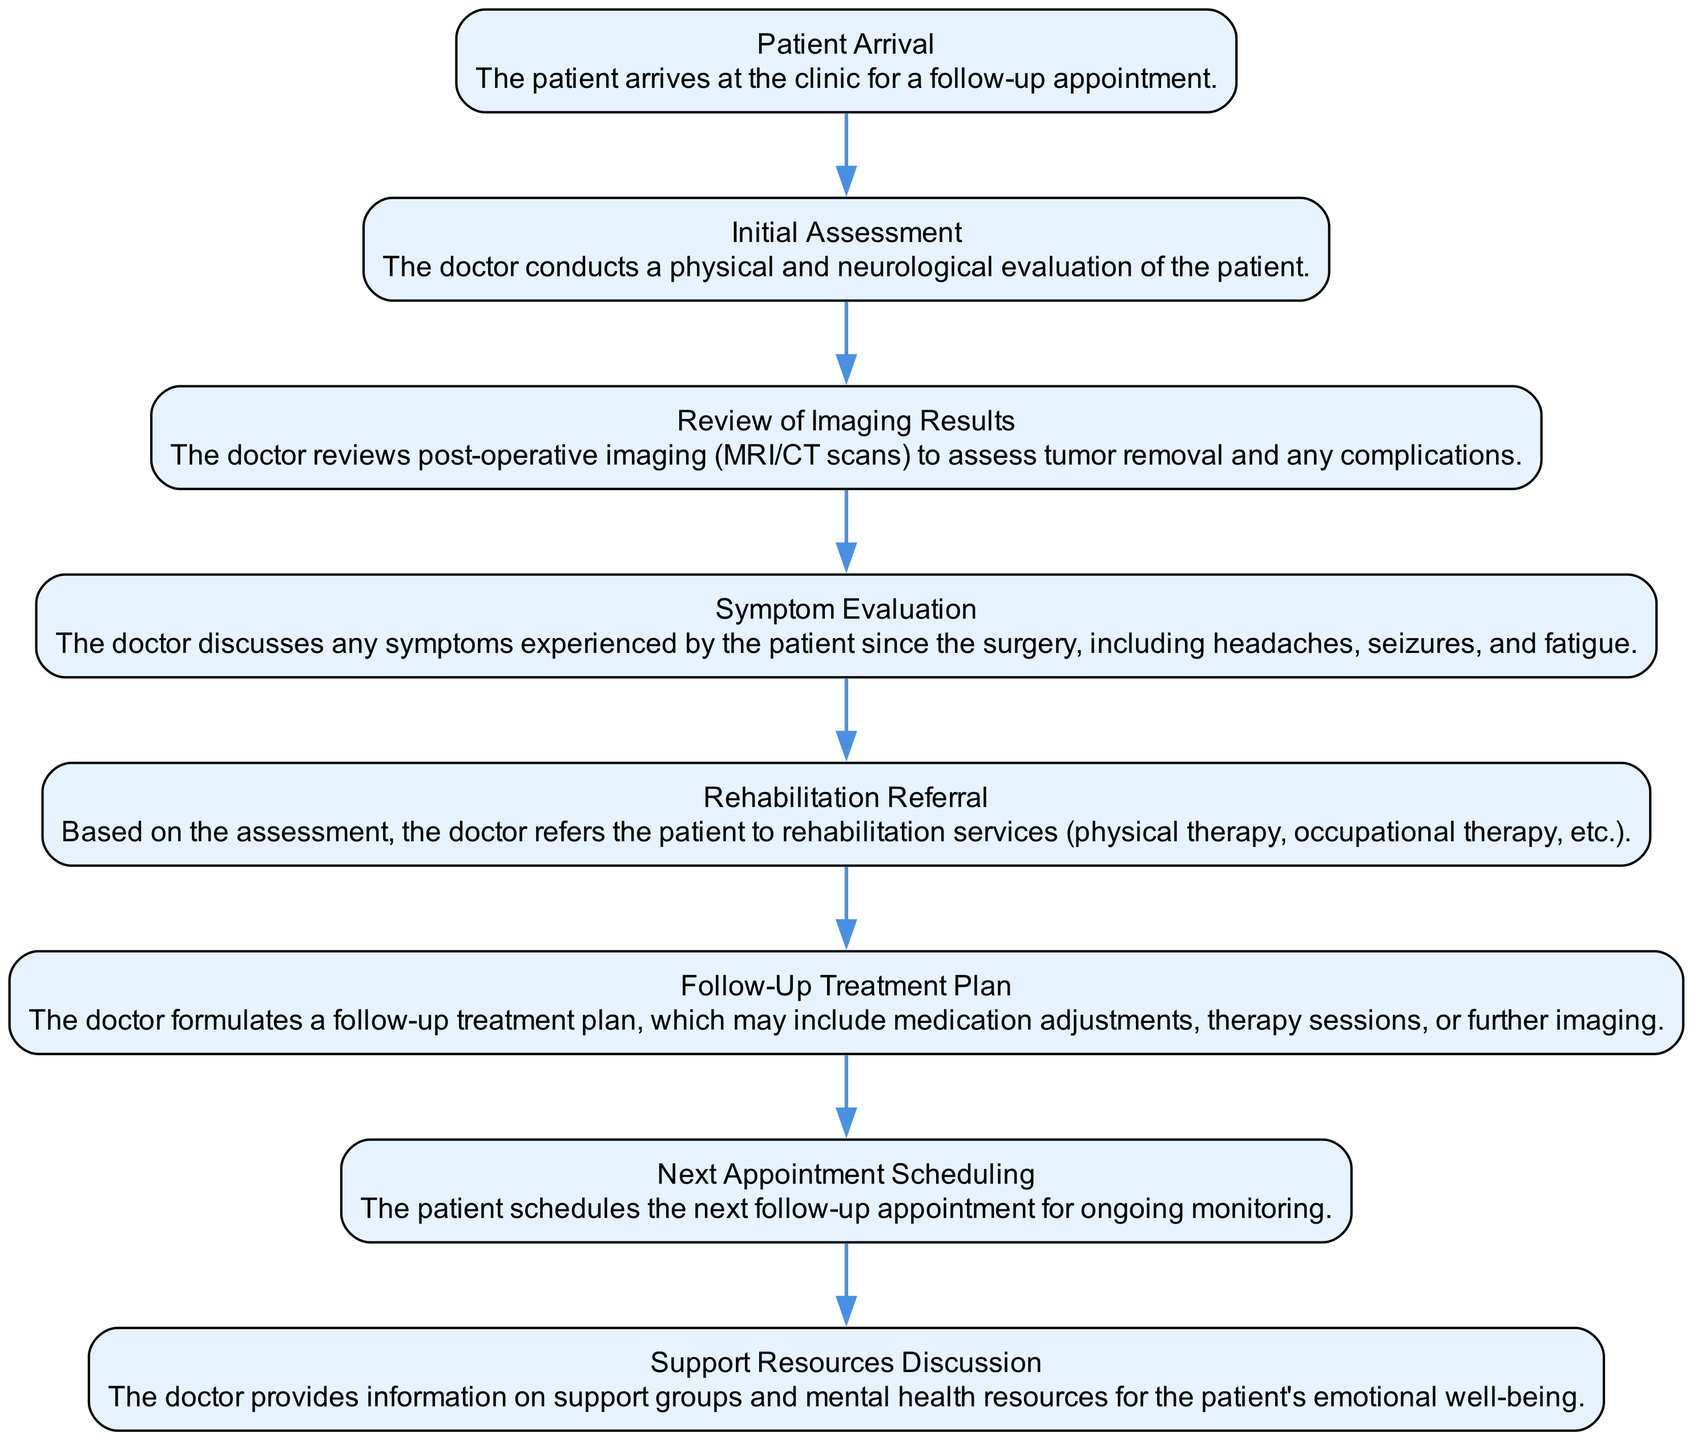What is the first step in the follow-up care process? The diagram shows the sequence of steps, starting with "Patient Arrival." This is the first node in the diagram, indicating the beginning of the follow-up care process.
Answer: Patient Arrival How many steps are there in the post-operative follow-up care timeline? By counting the nodes in the diagram, there are a total of eight distinct steps, which outline the entire follow-up care process for brain tumor patients.
Answer: 8 What does the doctor assess during the Initial Assessment? The "Initial Assessment" node describes that the doctor conducts a physical and neurological evaluation. This means that the doctor is looking at both physical health and the neurological aspects of the patient's well-being.
Answer: Physical and neurological evaluation Which step follows the "Review of Imaging Results"? The diagram indicates that "Symptom Evaluation" directly follows "Review of Imaging Results," illustrating the progression from reviewing results to discussing symptoms experienced by the patient.
Answer: Symptom Evaluation What services might the doctor refer the patient to after the symptom evaluation? The "Rehabilitation Referral" step specifies that the doctor may refer the patient to rehabilitation services such as physical therapy or occupational therapy for continued recovery and support.
Answer: Rehabilitation services What might be included in the Follow-Up Treatment Plan? The "Follow-Up Treatment Plan" step outlines that it could include medication adjustments, therapy sessions, or further imaging, illustrating the variety of treatment methods considered in the patient's ongoing care.
Answer: Medication adjustments, therapy sessions, further imaging What discussion occurs regarding emotional well-being? The "Support Resources Discussion" section indicates that the doctor provides information on support groups and mental health resources, showcasing the importance of emotional support during recovery.
Answer: Support groups and mental health resources How does the patient schedule their next appointment? The step "Next Appointment Scheduling" indicates that the patient actively engages in scheduling the next follow-up appointment after discussing their care plan, emphasizing self-management in their follow-up process.
Answer: Schedules next follow-up appointment 